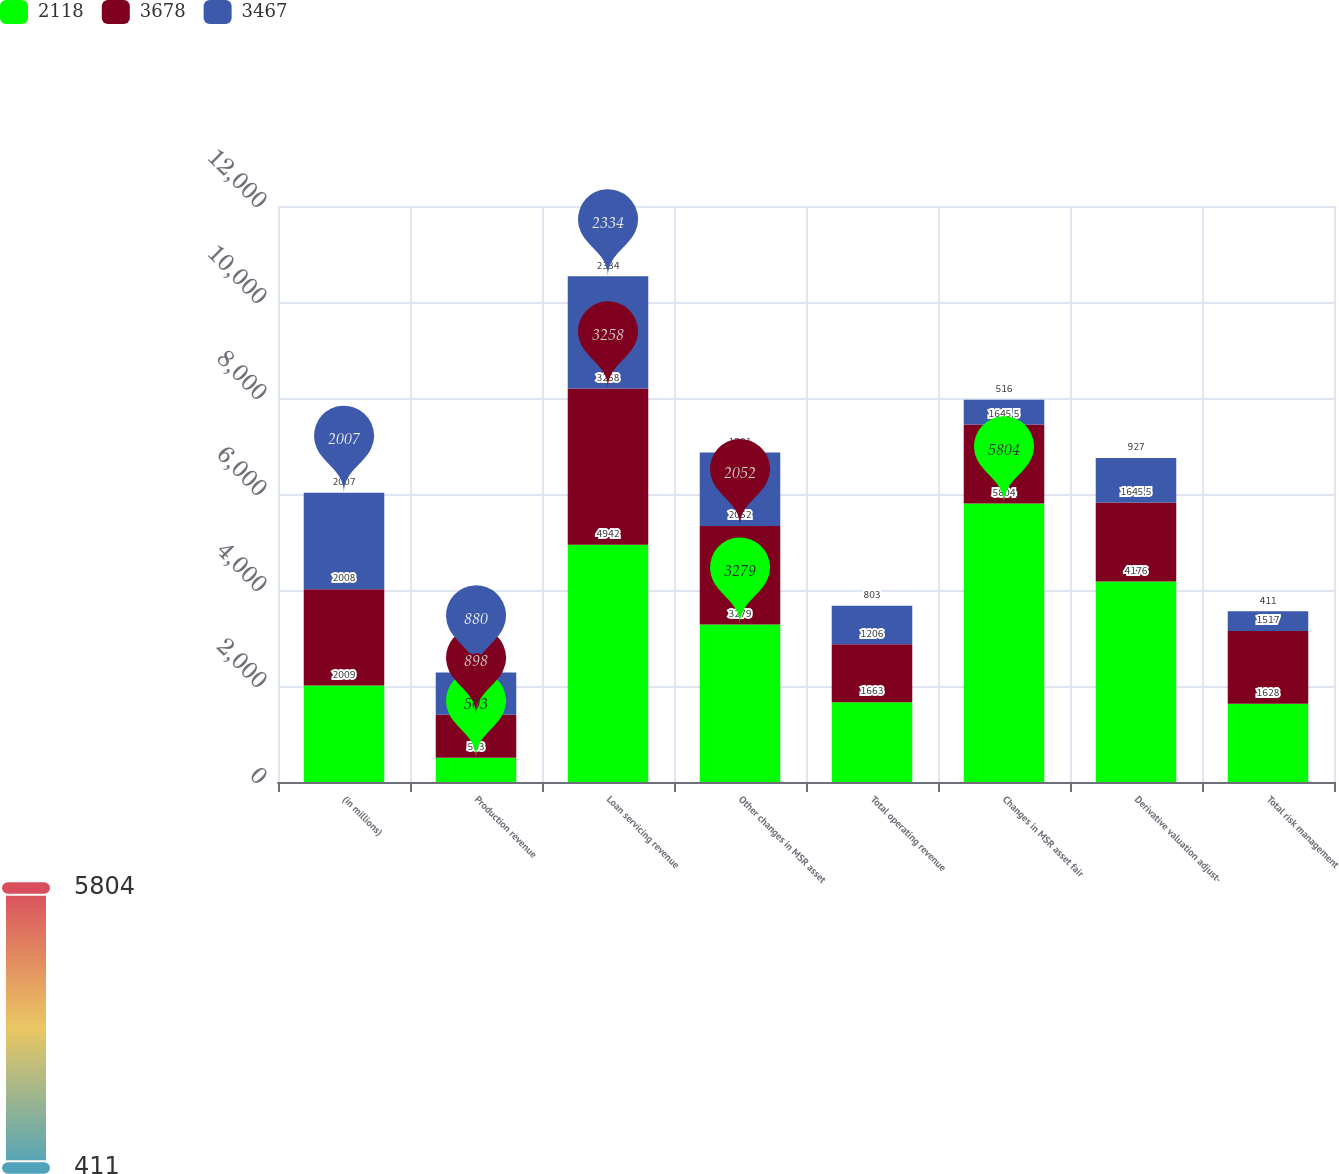<chart> <loc_0><loc_0><loc_500><loc_500><stacked_bar_chart><ecel><fcel>(in millions)<fcel>Production revenue<fcel>Loan servicing revenue<fcel>Other changes in MSR asset<fcel>Total operating revenue<fcel>Changes in MSR asset fair<fcel>Derivative valuation adjust-<fcel>Total risk management<nl><fcel>2118<fcel>2009<fcel>503<fcel>4942<fcel>3279<fcel>1663<fcel>5804<fcel>4176<fcel>1628<nl><fcel>3678<fcel>2008<fcel>898<fcel>3258<fcel>2052<fcel>1206<fcel>1645.5<fcel>1645.5<fcel>1517<nl><fcel>3467<fcel>2007<fcel>880<fcel>2334<fcel>1531<fcel>803<fcel>516<fcel>927<fcel>411<nl></chart> 